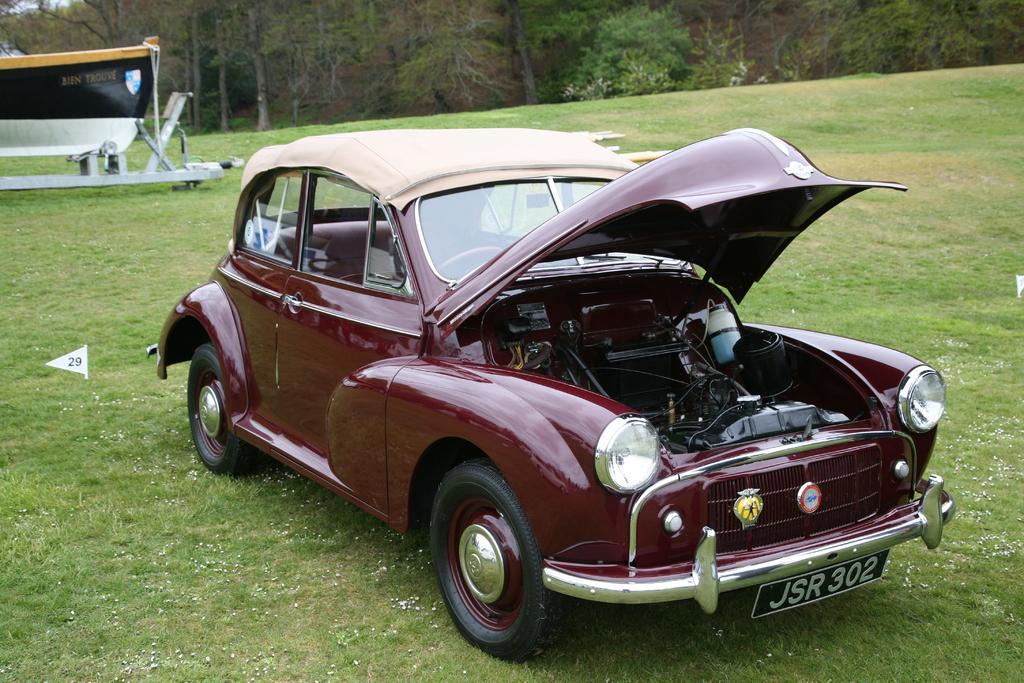Describe this image in one or two sentences. In this image we can see a vehicle on the grass and we can see a flag with number near the vehicle. In the background, we can see a banner with text and logo attached to the stand and there are trees. 